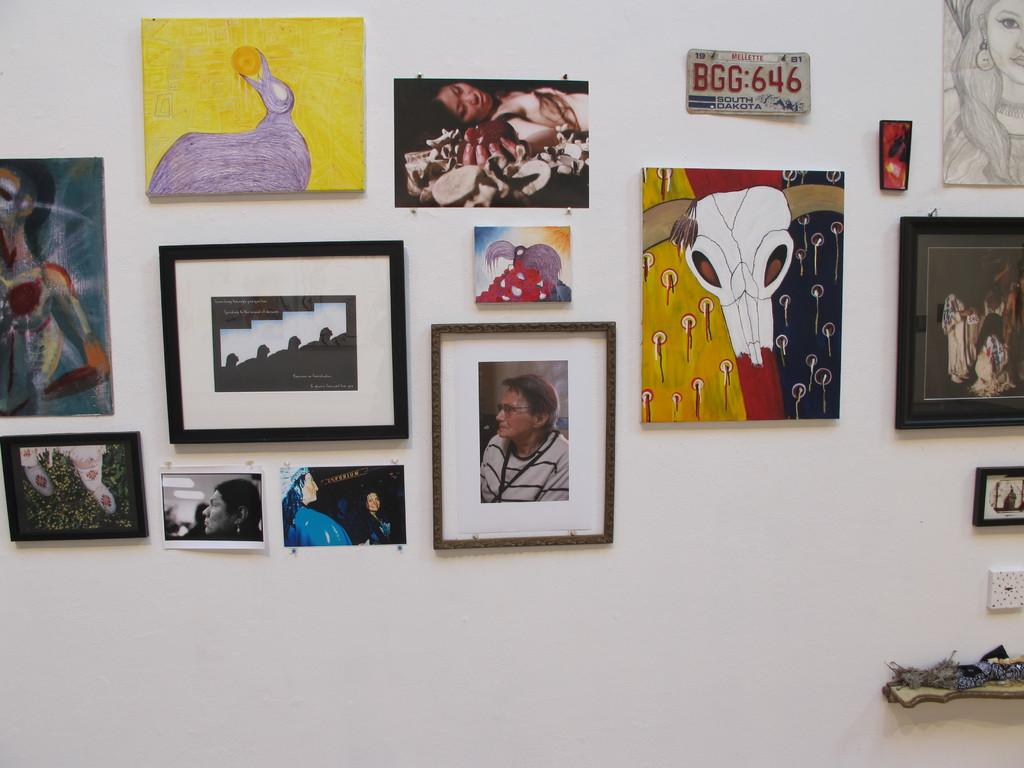What objects are visible in the image? There are different kinds of photo frames in the image. Where are the photo frames located? The photo frames are on a white-colored wall. Can you tell me how many zippers are attached to the photo frames in the image? There are no zippers present on the photo frames in the image. What type of window can be seen in the image? There is no window present in the image; it only features photo frames on a white-colored wall. 